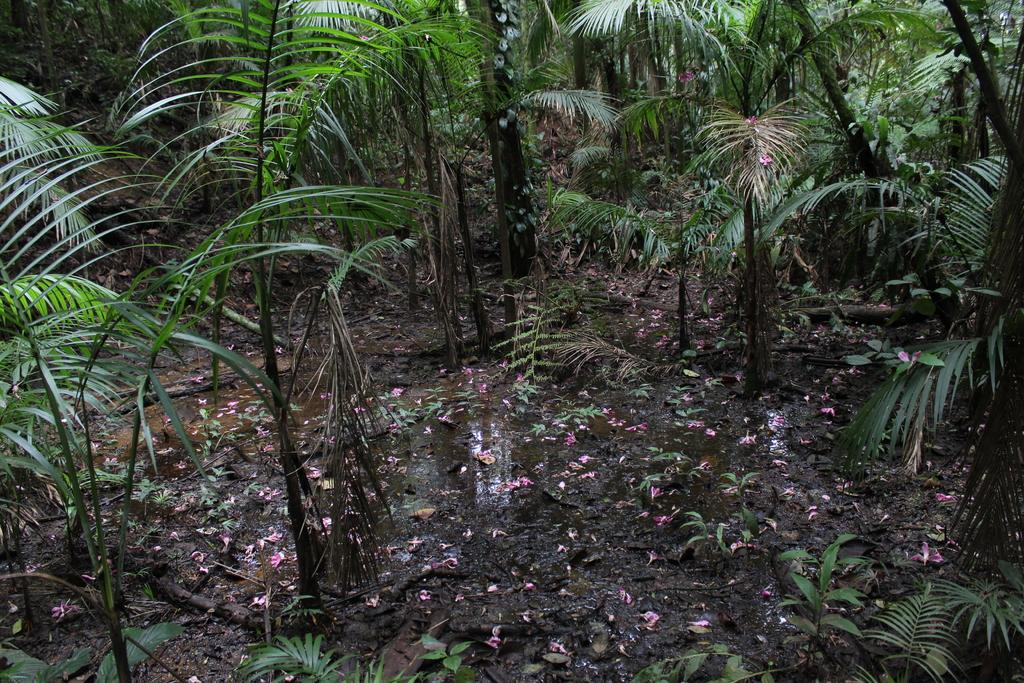What is located at the bottom of the picture? There are plants, soil, pink flowers, and water at the bottom of the picture. What type of vegetation can be seen at the bottom of the picture? Pink flowers are visible at the bottom of the picture. What is the background of the picture composed of? There are trees in the background of the picture. What is the name of the jellyfish swimming in the water at the bottom of the picture? There are no jellyfish present in the image; it only features plants, soil, pink flowers, and water at the bottom, along with trees in the background. 